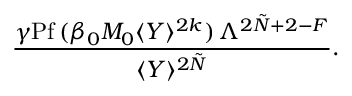Convert formula to latex. <formula><loc_0><loc_0><loc_500><loc_500>\frac { \gamma P f \, ( \beta _ { 0 } M _ { 0 } \langle Y \rangle ^ { 2 k } ) \, \Lambda ^ { 2 \tilde { N } + 2 - F } } { \langle Y \rangle ^ { 2 \tilde { N } } } .</formula> 